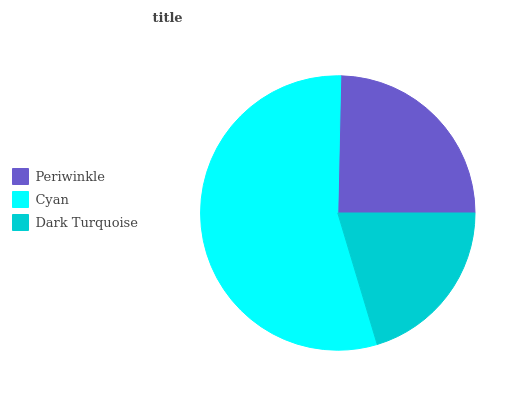Is Dark Turquoise the minimum?
Answer yes or no. Yes. Is Cyan the maximum?
Answer yes or no. Yes. Is Cyan the minimum?
Answer yes or no. No. Is Dark Turquoise the maximum?
Answer yes or no. No. Is Cyan greater than Dark Turquoise?
Answer yes or no. Yes. Is Dark Turquoise less than Cyan?
Answer yes or no. Yes. Is Dark Turquoise greater than Cyan?
Answer yes or no. No. Is Cyan less than Dark Turquoise?
Answer yes or no. No. Is Periwinkle the high median?
Answer yes or no. Yes. Is Periwinkle the low median?
Answer yes or no. Yes. Is Cyan the high median?
Answer yes or no. No. Is Cyan the low median?
Answer yes or no. No. 